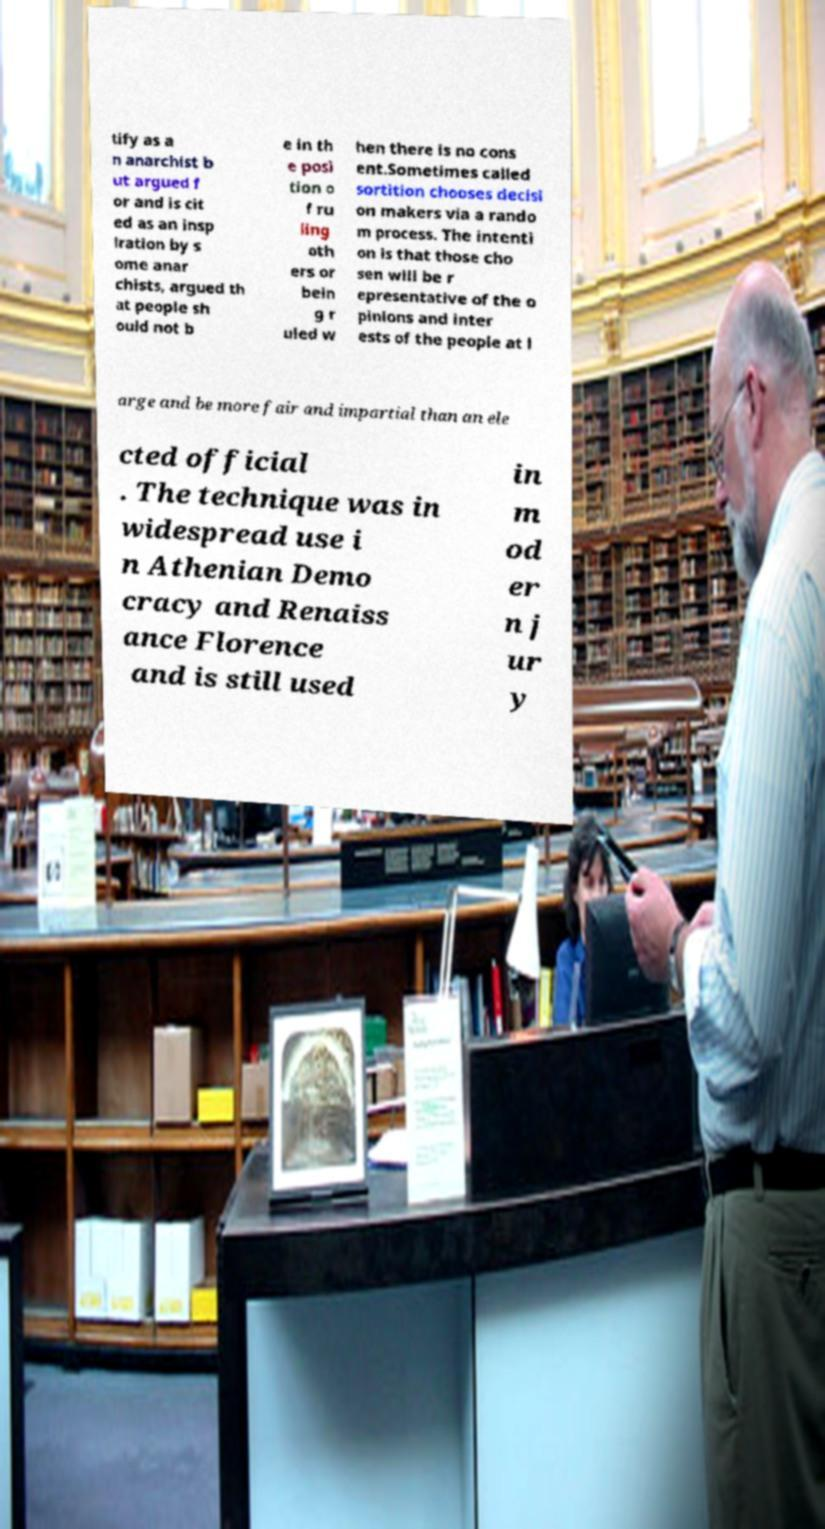For documentation purposes, I need the text within this image transcribed. Could you provide that? tify as a n anarchist b ut argued f or and is cit ed as an insp iration by s ome anar chists, argued th at people sh ould not b e in th e posi tion o f ru ling oth ers or bein g r uled w hen there is no cons ent.Sometimes called sortition chooses decisi on makers via a rando m process. The intenti on is that those cho sen will be r epresentative of the o pinions and inter ests of the people at l arge and be more fair and impartial than an ele cted official . The technique was in widespread use i n Athenian Demo cracy and Renaiss ance Florence and is still used in m od er n j ur y 